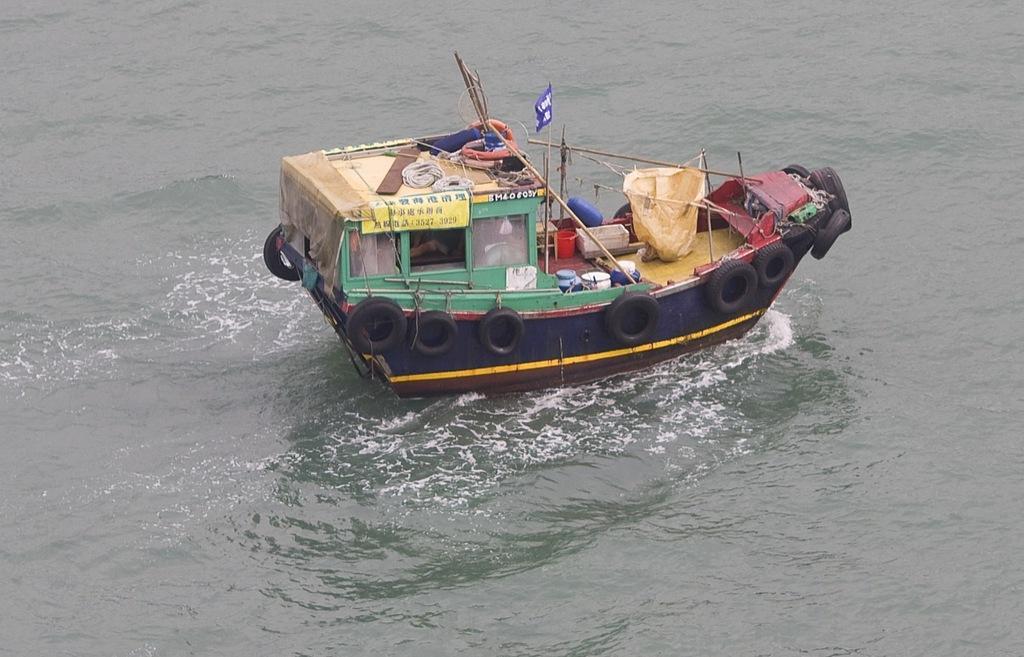In one or two sentences, can you explain what this image depicts? In this picture we can see water at the bottom, there is a boat in the middle, we can also see some tyres, ropes, a flag and sticks. 